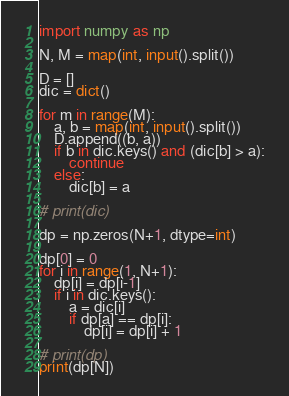<code> <loc_0><loc_0><loc_500><loc_500><_Python_>import numpy as np

N, M = map(int, input().split())

D = []
dic = dict()

for m in range(M):
    a, b = map(int, input().split())
    D.append((b, a))
    if b in dic.keys() and (dic[b] > a):
        continue
    else:
        dic[b] = a
    
# print(dic)

dp = np.zeros(N+1, dtype=int)

dp[0] = 0
for i in range(1, N+1):
    dp[i] = dp[i-1]
    if i in dic.keys():
        a = dic[i]
        if dp[a] == dp[i]:
            dp[i] = dp[i] + 1

# print(dp)
print(dp[N])    
</code> 